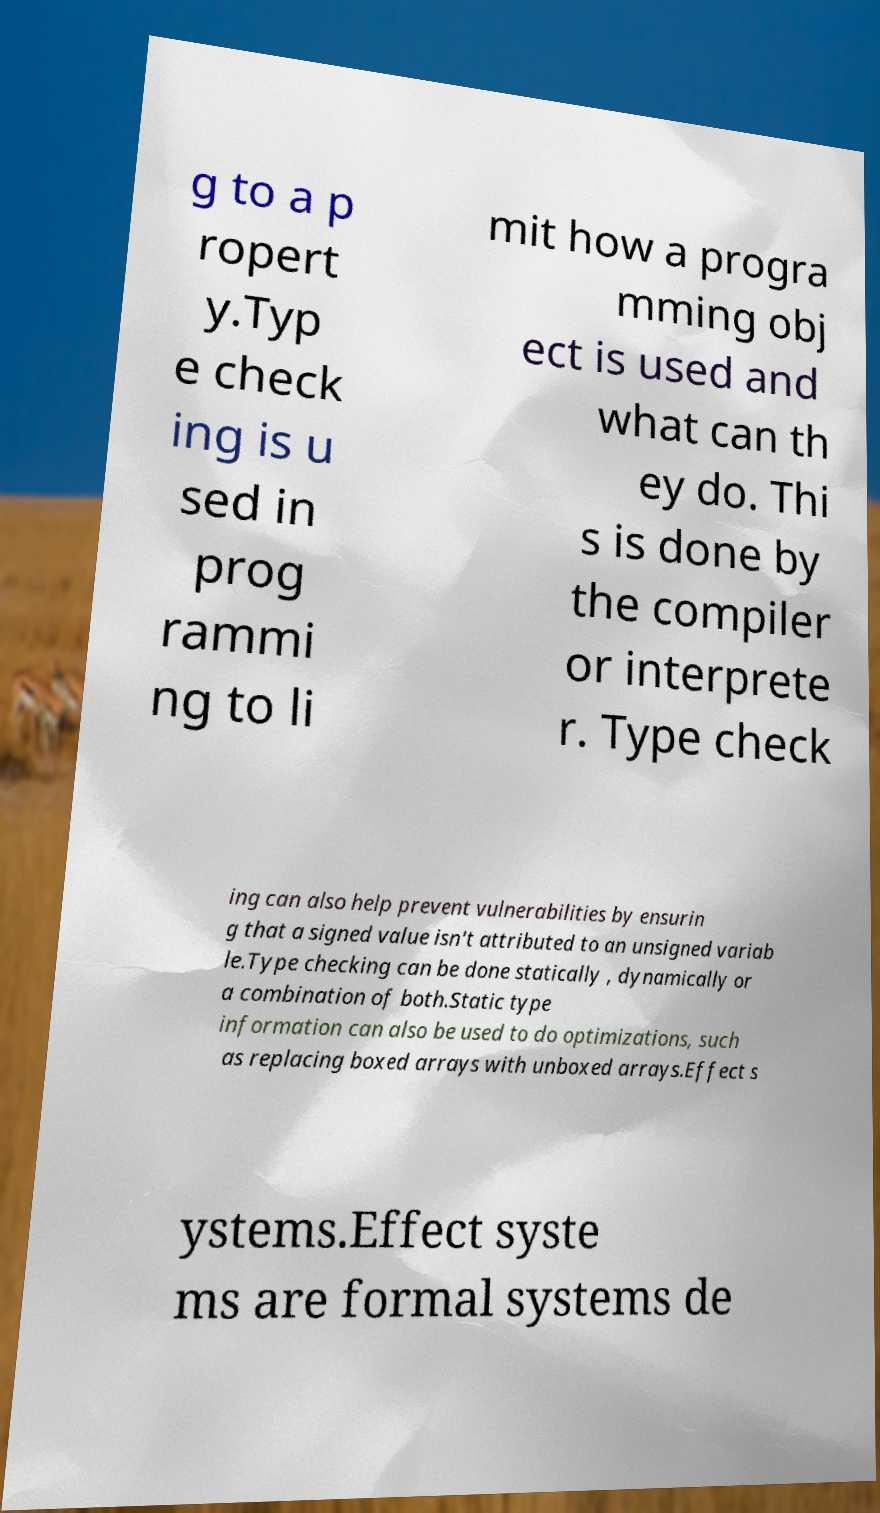Could you extract and type out the text from this image? g to a p ropert y.Typ e check ing is u sed in prog rammi ng to li mit how a progra mming obj ect is used and what can th ey do. Thi s is done by the compiler or interprete r. Type check ing can also help prevent vulnerabilities by ensurin g that a signed value isn't attributed to an unsigned variab le.Type checking can be done statically , dynamically or a combination of both.Static type information can also be used to do optimizations, such as replacing boxed arrays with unboxed arrays.Effect s ystems.Effect syste ms are formal systems de 